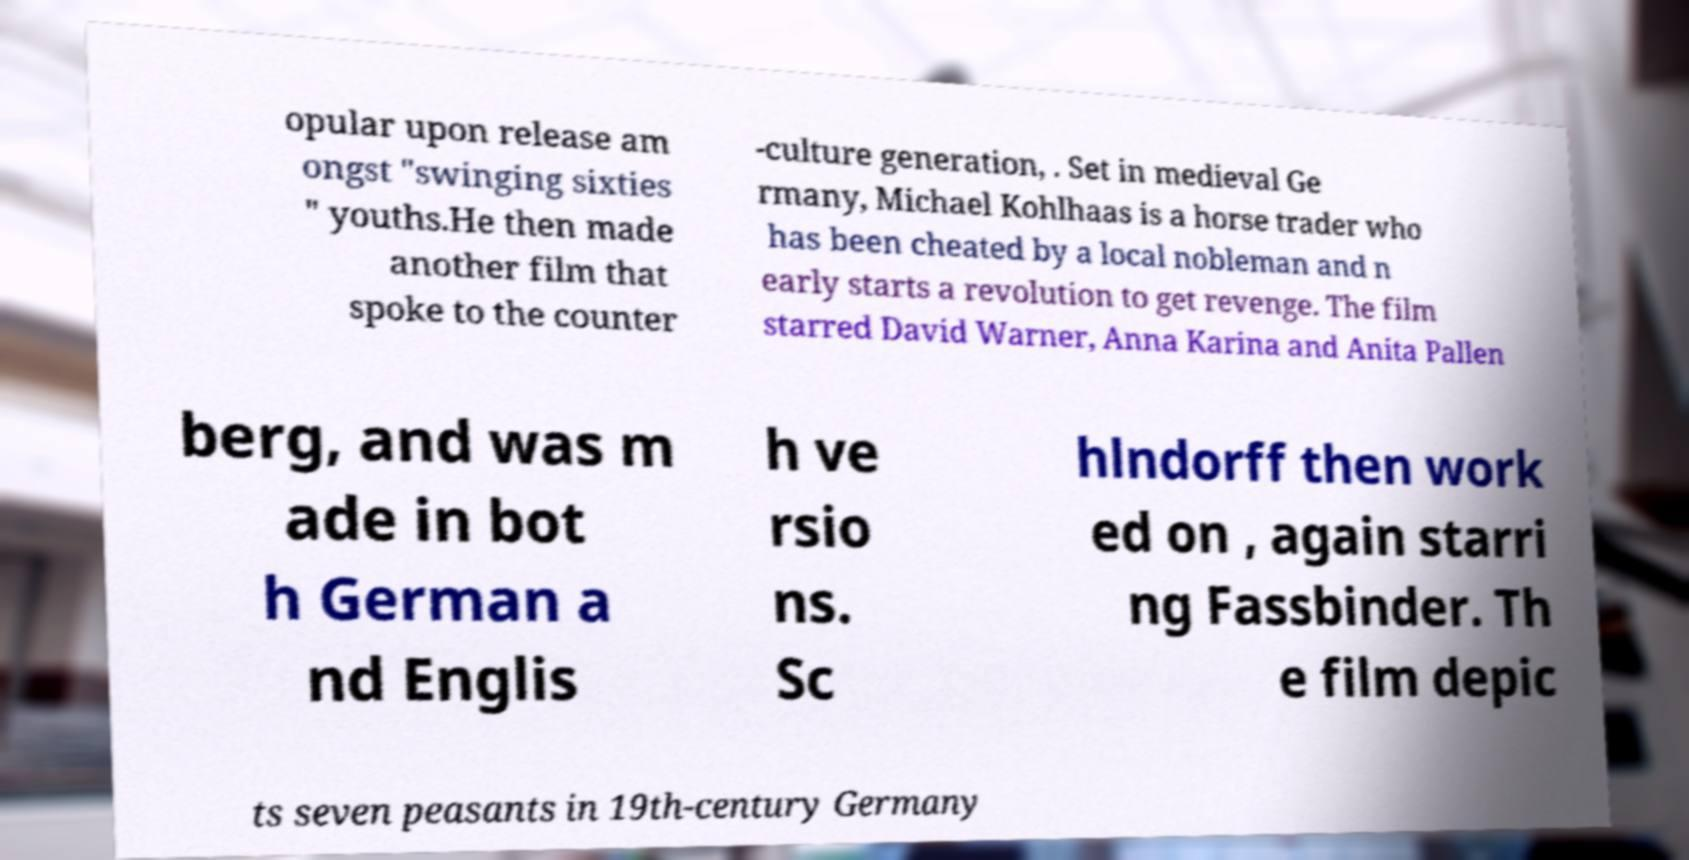Can you accurately transcribe the text from the provided image for me? opular upon release am ongst "swinging sixties " youths.He then made another film that spoke to the counter -culture generation, . Set in medieval Ge rmany, Michael Kohlhaas is a horse trader who has been cheated by a local nobleman and n early starts a revolution to get revenge. The film starred David Warner, Anna Karina and Anita Pallen berg, and was m ade in bot h German a nd Englis h ve rsio ns. Sc hlndorff then work ed on , again starri ng Fassbinder. Th e film depic ts seven peasants in 19th-century Germany 